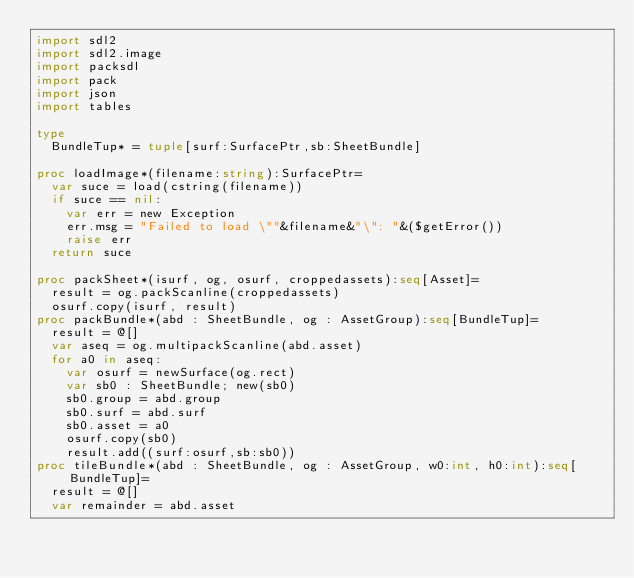<code> <loc_0><loc_0><loc_500><loc_500><_Nim_>import sdl2
import sdl2.image
import packsdl
import pack
import json
import tables

type
  BundleTup* = tuple[surf:SurfacePtr,sb:SheetBundle]

proc loadImage*(filename:string):SurfacePtr=
  var suce = load(cstring(filename))  
  if suce == nil:
    var err = new Exception
    err.msg = "Failed to load \""&filename&"\": "&($getError())
    raise err
  return suce

proc packSheet*(isurf, og, osurf, croppedassets):seq[Asset]=
  result = og.packScanline(croppedassets)
  osurf.copy(isurf, result)
proc packBundle*(abd : SheetBundle, og : AssetGroup):seq[BundleTup]=
  result = @[]
  var aseq = og.multipackScanline(abd.asset)
  for a0 in aseq:
    var osurf = newSurface(og.rect)
    var sb0 : SheetBundle; new(sb0)
    sb0.group = abd.group
    sb0.surf = abd.surf
    sb0.asset = a0
    osurf.copy(sb0)
    result.add((surf:osurf,sb:sb0))
proc tileBundle*(abd : SheetBundle, og : AssetGroup, w0:int, h0:int):seq[BundleTup]=
  result = @[]
  var remainder = abd.asset</code> 